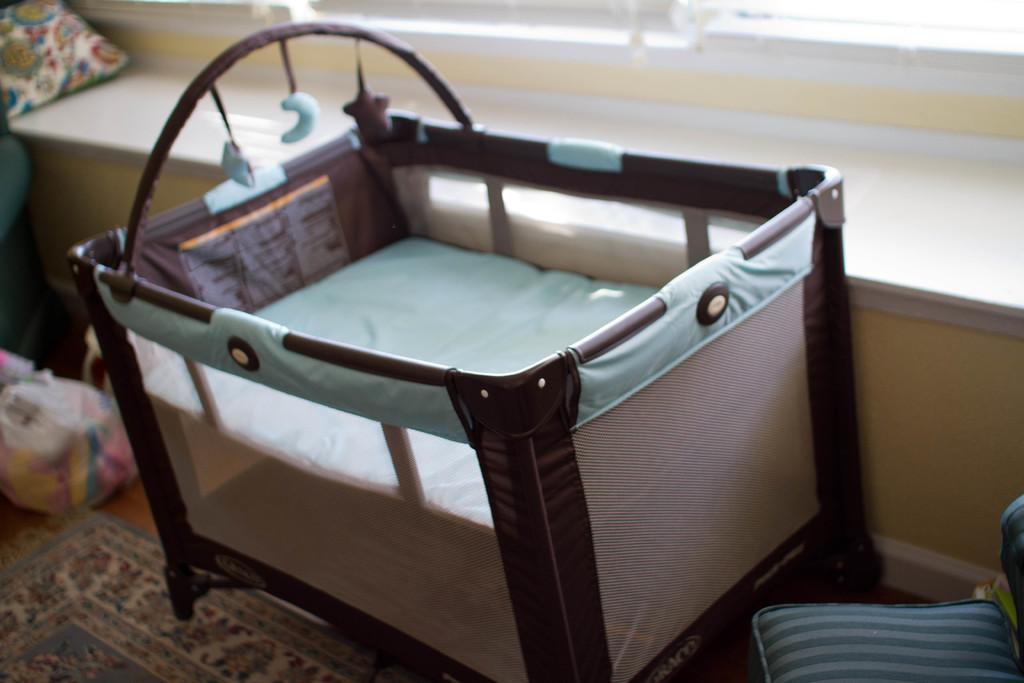In one or two sentences, can you explain what this image depicts? In this picture we can see a carpet, bag and a crib on the floor and in the background we can see a pillow on a platform. 